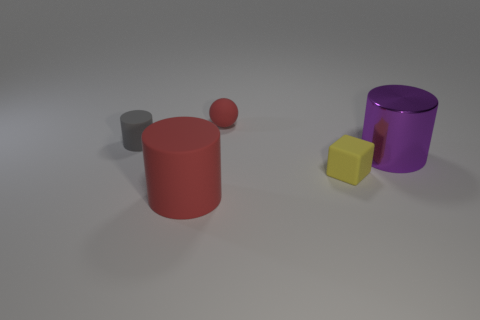What kind of texture or finish do the objects in the image have? The objects in the image all appear to have a smooth and matte finish, without any visible patterns or roughness. The lighting suggests a soft reflection indicating that the surfaces are likely non-glossy. 